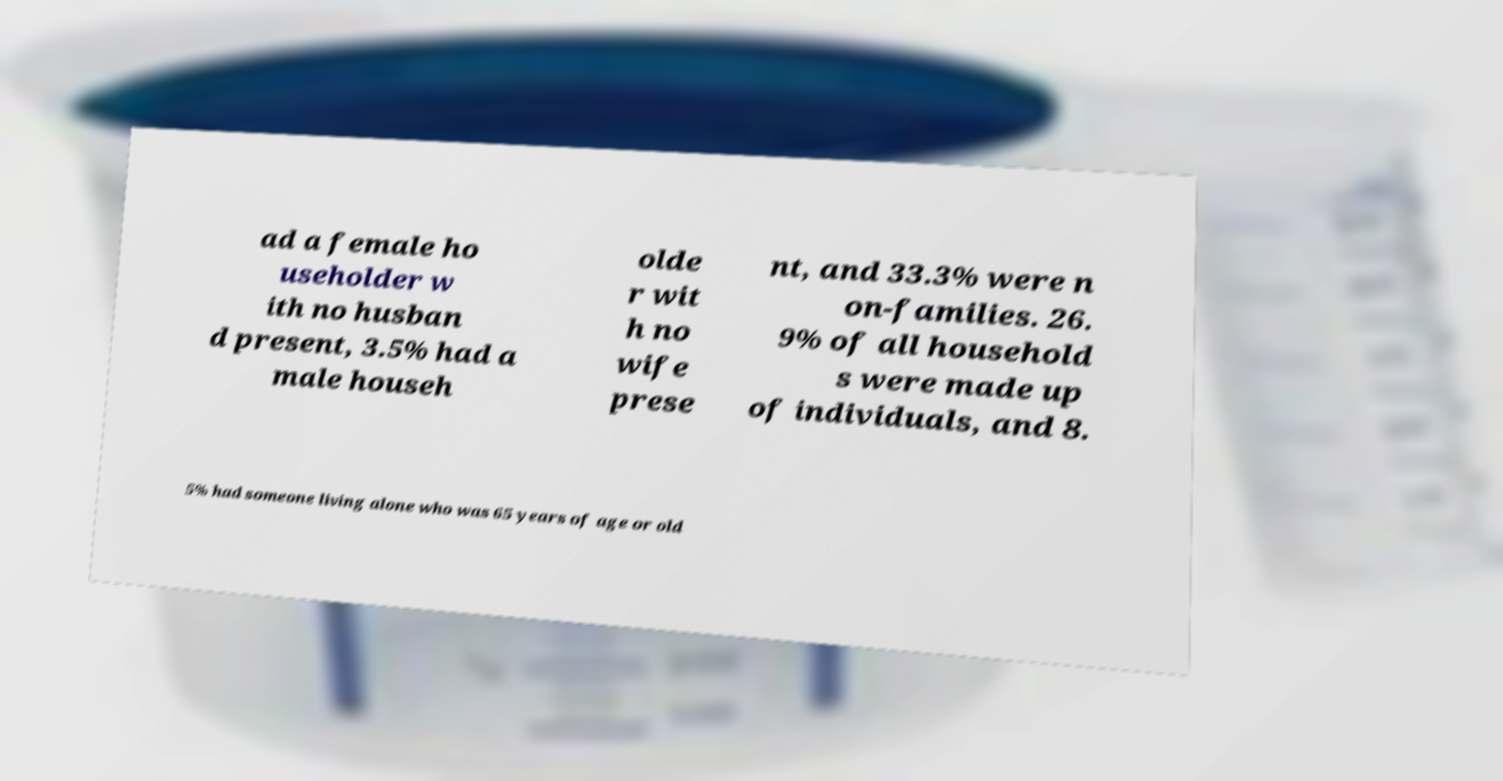Please identify and transcribe the text found in this image. ad a female ho useholder w ith no husban d present, 3.5% had a male househ olde r wit h no wife prese nt, and 33.3% were n on-families. 26. 9% of all household s were made up of individuals, and 8. 5% had someone living alone who was 65 years of age or old 